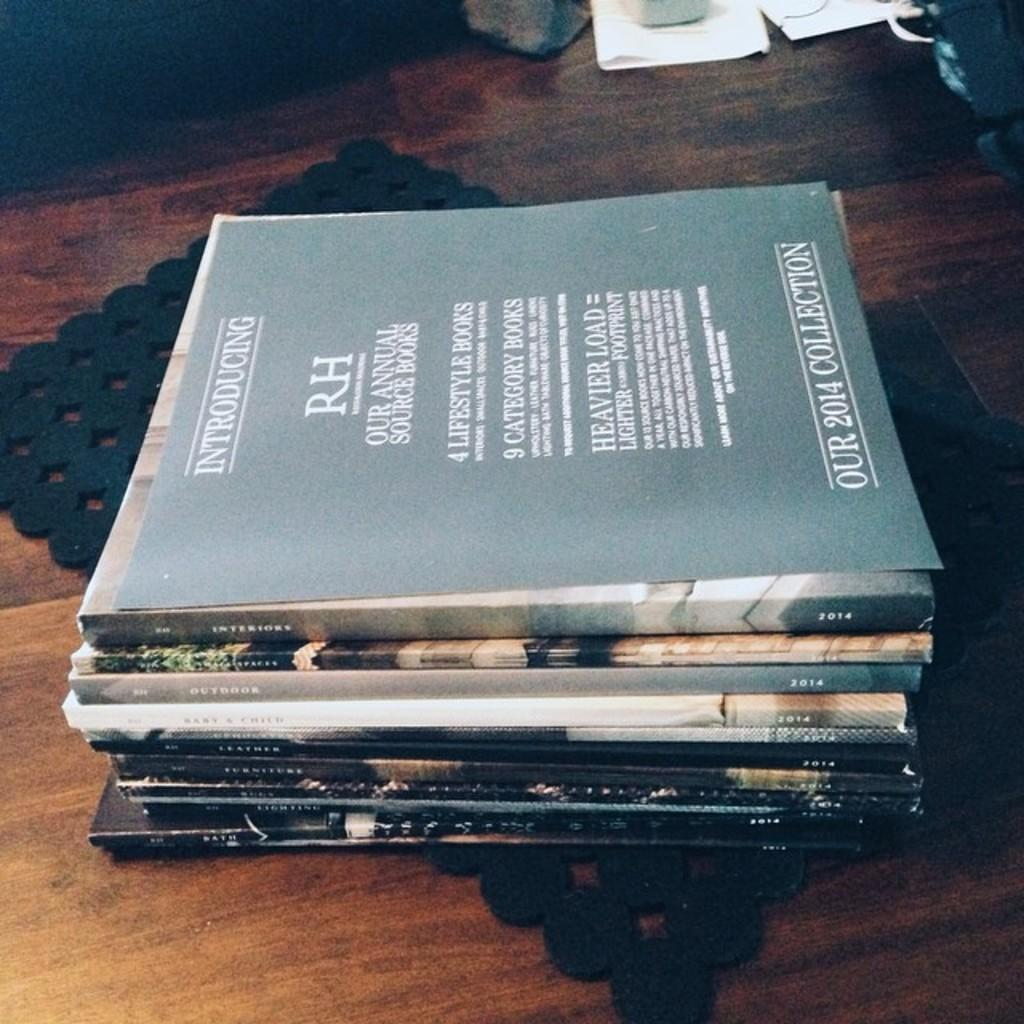<image>
Provide a brief description of the given image. The  2014 collection of an annual book is displayed on a table. 